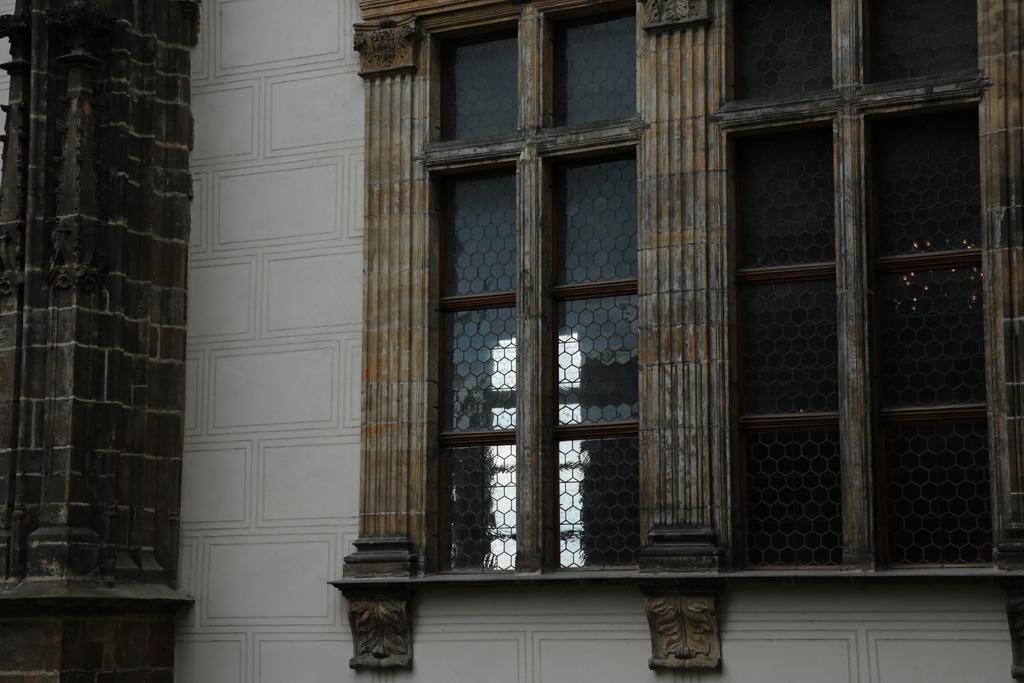Could you give a brief overview of what you see in this image? In this image there is a building and we can see windows and a pillar. 